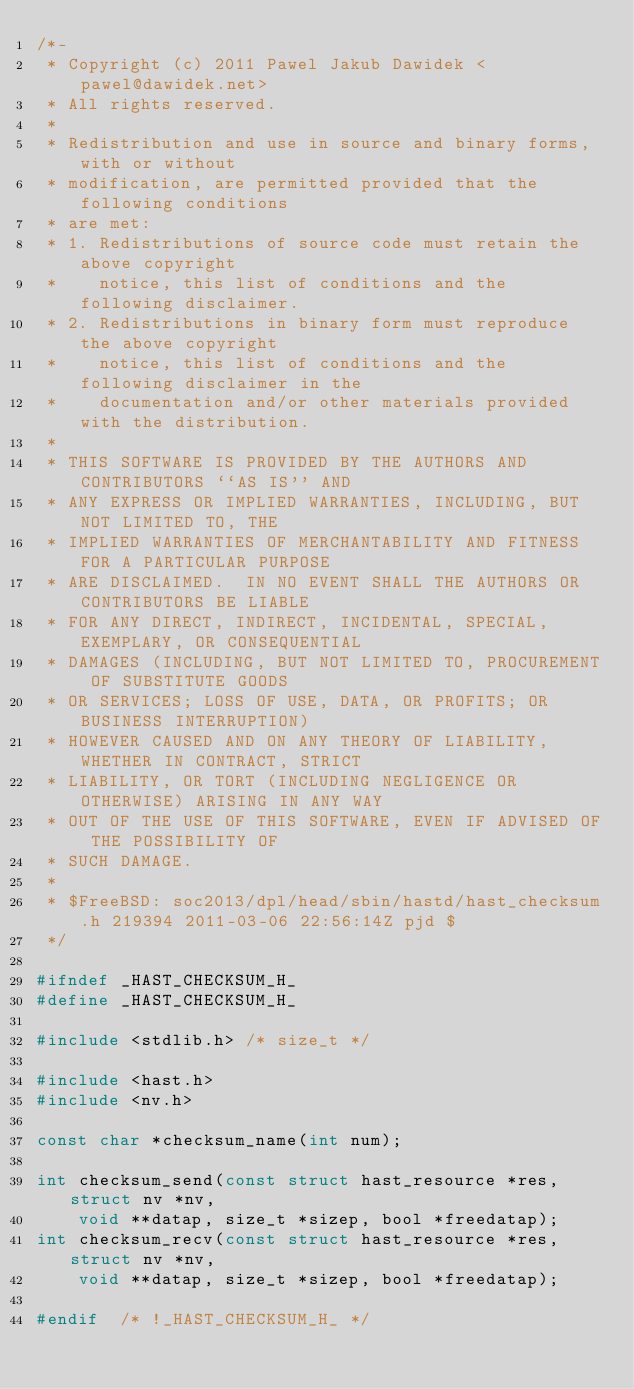Convert code to text. <code><loc_0><loc_0><loc_500><loc_500><_C_>/*-
 * Copyright (c) 2011 Pawel Jakub Dawidek <pawel@dawidek.net>
 * All rights reserved.
 *
 * Redistribution and use in source and binary forms, with or without
 * modification, are permitted provided that the following conditions
 * are met:
 * 1. Redistributions of source code must retain the above copyright
 *    notice, this list of conditions and the following disclaimer.
 * 2. Redistributions in binary form must reproduce the above copyright
 *    notice, this list of conditions and the following disclaimer in the
 *    documentation and/or other materials provided with the distribution.
 *
 * THIS SOFTWARE IS PROVIDED BY THE AUTHORS AND CONTRIBUTORS ``AS IS'' AND
 * ANY EXPRESS OR IMPLIED WARRANTIES, INCLUDING, BUT NOT LIMITED TO, THE
 * IMPLIED WARRANTIES OF MERCHANTABILITY AND FITNESS FOR A PARTICULAR PURPOSE
 * ARE DISCLAIMED.  IN NO EVENT SHALL THE AUTHORS OR CONTRIBUTORS BE LIABLE
 * FOR ANY DIRECT, INDIRECT, INCIDENTAL, SPECIAL, EXEMPLARY, OR CONSEQUENTIAL
 * DAMAGES (INCLUDING, BUT NOT LIMITED TO, PROCUREMENT OF SUBSTITUTE GOODS
 * OR SERVICES; LOSS OF USE, DATA, OR PROFITS; OR BUSINESS INTERRUPTION)
 * HOWEVER CAUSED AND ON ANY THEORY OF LIABILITY, WHETHER IN CONTRACT, STRICT
 * LIABILITY, OR TORT (INCLUDING NEGLIGENCE OR OTHERWISE) ARISING IN ANY WAY
 * OUT OF THE USE OF THIS SOFTWARE, EVEN IF ADVISED OF THE POSSIBILITY OF
 * SUCH DAMAGE.
 *
 * $FreeBSD: soc2013/dpl/head/sbin/hastd/hast_checksum.h 219394 2011-03-06 22:56:14Z pjd $
 */

#ifndef	_HAST_CHECKSUM_H_
#define	_HAST_CHECKSUM_H_

#include <stdlib.h>	/* size_t */

#include <hast.h>
#include <nv.h>

const char *checksum_name(int num);

int checksum_send(const struct hast_resource *res, struct nv *nv,
    void **datap, size_t *sizep, bool *freedatap);
int checksum_recv(const struct hast_resource *res, struct nv *nv,
    void **datap, size_t *sizep, bool *freedatap);

#endif	/* !_HAST_CHECKSUM_H_ */
</code> 